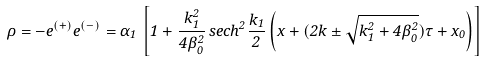<formula> <loc_0><loc_0><loc_500><loc_500>\rho = - e ^ { ( + ) } e ^ { ( - ) } = \alpha _ { 1 } \, \left [ 1 + \frac { k ^ { 2 } _ { 1 } } { 4 \beta ^ { 2 } _ { 0 } } \, s e c h ^ { 2 } \frac { k _ { 1 } } { 2 } \left ( x + ( 2 k \pm \sqrt { k _ { 1 } ^ { 2 } + 4 \beta ^ { 2 } _ { 0 } } ) \tau + x _ { 0 } \right ) \right ]</formula> 